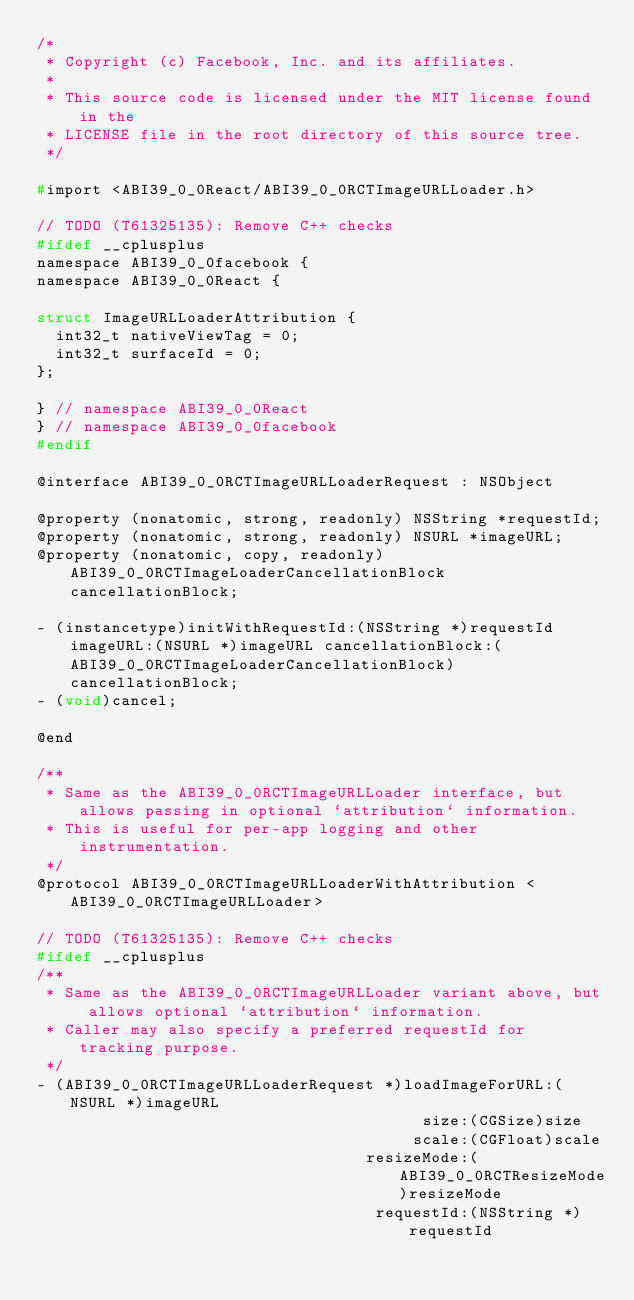Convert code to text. <code><loc_0><loc_0><loc_500><loc_500><_C_>/*
 * Copyright (c) Facebook, Inc. and its affiliates.
 *
 * This source code is licensed under the MIT license found in the
 * LICENSE file in the root directory of this source tree.
 */

#import <ABI39_0_0React/ABI39_0_0RCTImageURLLoader.h>

// TODO (T61325135): Remove C++ checks
#ifdef __cplusplus
namespace ABI39_0_0facebook {
namespace ABI39_0_0React {

struct ImageURLLoaderAttribution {
  int32_t nativeViewTag = 0;
  int32_t surfaceId = 0;
};

} // namespace ABI39_0_0React
} // namespace ABI39_0_0facebook
#endif

@interface ABI39_0_0RCTImageURLLoaderRequest : NSObject

@property (nonatomic, strong, readonly) NSString *requestId;
@property (nonatomic, strong, readonly) NSURL *imageURL;
@property (nonatomic, copy, readonly) ABI39_0_0RCTImageLoaderCancellationBlock cancellationBlock;

- (instancetype)initWithRequestId:(NSString *)requestId imageURL:(NSURL *)imageURL cancellationBlock:(ABI39_0_0RCTImageLoaderCancellationBlock)cancellationBlock;
- (void)cancel;

@end

/**
 * Same as the ABI39_0_0RCTImageURLLoader interface, but allows passing in optional `attribution` information.
 * This is useful for per-app logging and other instrumentation.
 */
@protocol ABI39_0_0RCTImageURLLoaderWithAttribution <ABI39_0_0RCTImageURLLoader>

// TODO (T61325135): Remove C++ checks
#ifdef __cplusplus
/**
 * Same as the ABI39_0_0RCTImageURLLoader variant above, but allows optional `attribution` information.
 * Caller may also specify a preferred requestId for tracking purpose.
 */
- (ABI39_0_0RCTImageURLLoaderRequest *)loadImageForURL:(NSURL *)imageURL
                                         size:(CGSize)size
                                        scale:(CGFloat)scale
                                   resizeMode:(ABI39_0_0RCTResizeMode)resizeMode
                                    requestId:(NSString *)requestId</code> 